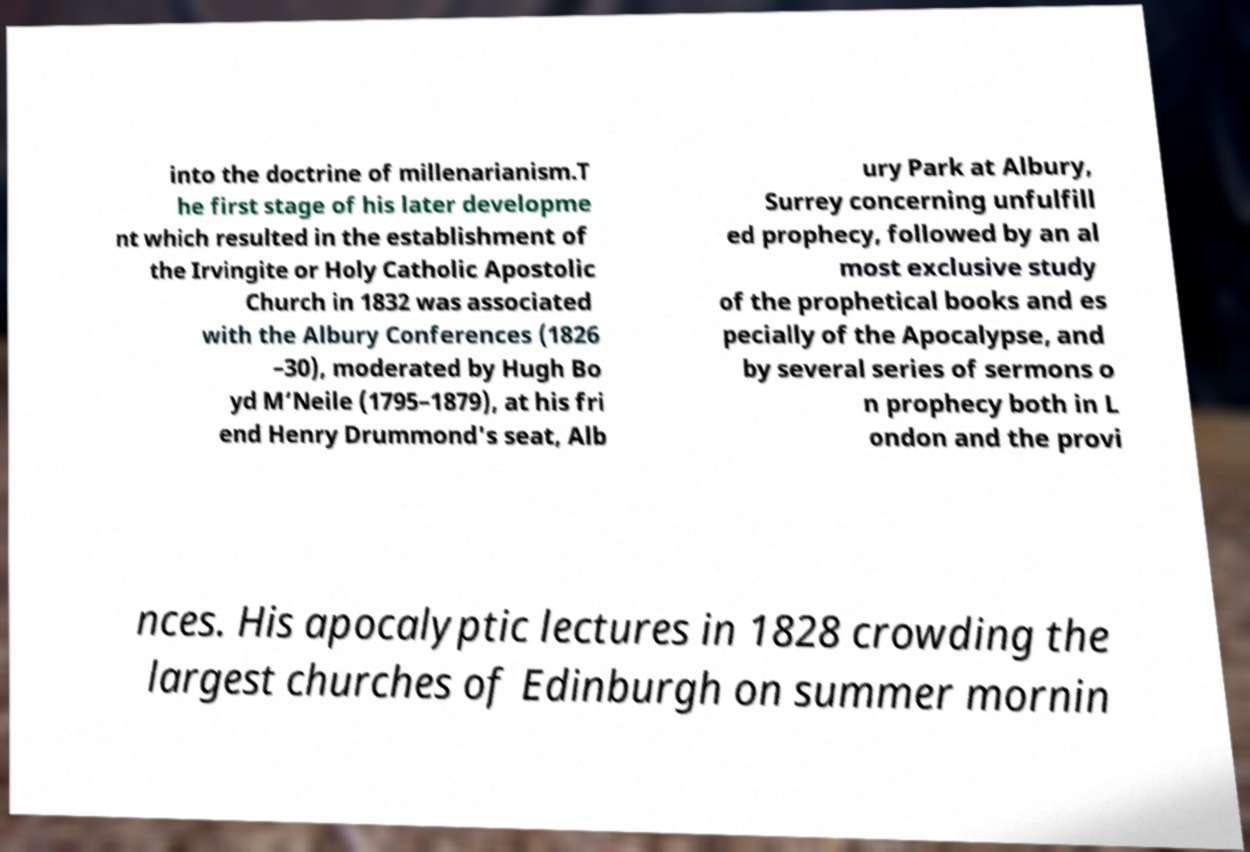Could you extract and type out the text from this image? into the doctrine of millenarianism.T he first stage of his later developme nt which resulted in the establishment of the Irvingite or Holy Catholic Apostolic Church in 1832 was associated with the Albury Conferences (1826 –30), moderated by Hugh Bo yd M‘Neile (1795–1879), at his fri end Henry Drummond's seat, Alb ury Park at Albury, Surrey concerning unfulfill ed prophecy, followed by an al most exclusive study of the prophetical books and es pecially of the Apocalypse, and by several series of sermons o n prophecy both in L ondon and the provi nces. His apocalyptic lectures in 1828 crowding the largest churches of Edinburgh on summer mornin 